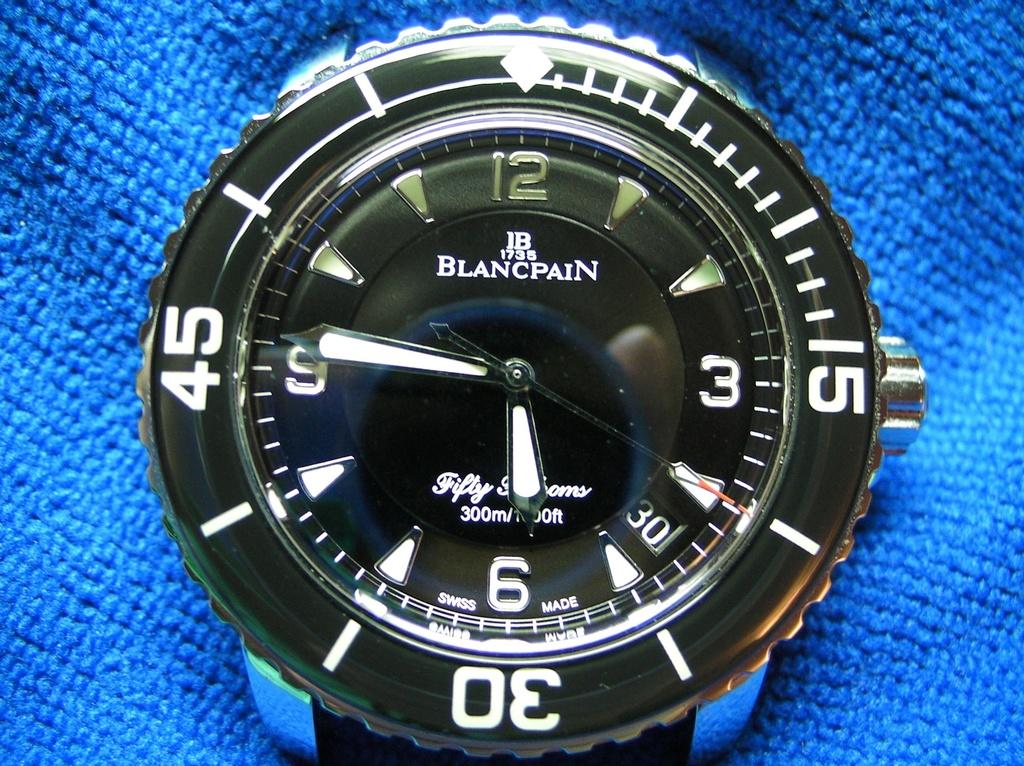<image>
Create a compact narrative representing the image presented. A wrist watch with the hands on six and nine. 